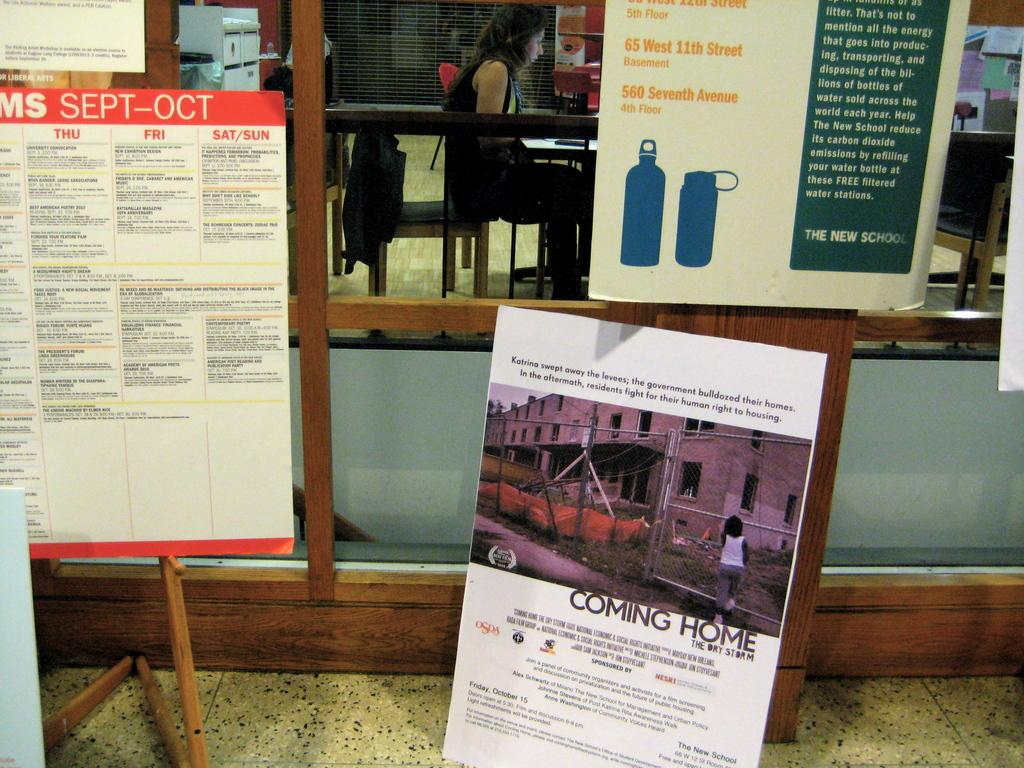<image>
Describe the image concisely. A poster sitting on the floor advertises Coming Home. 